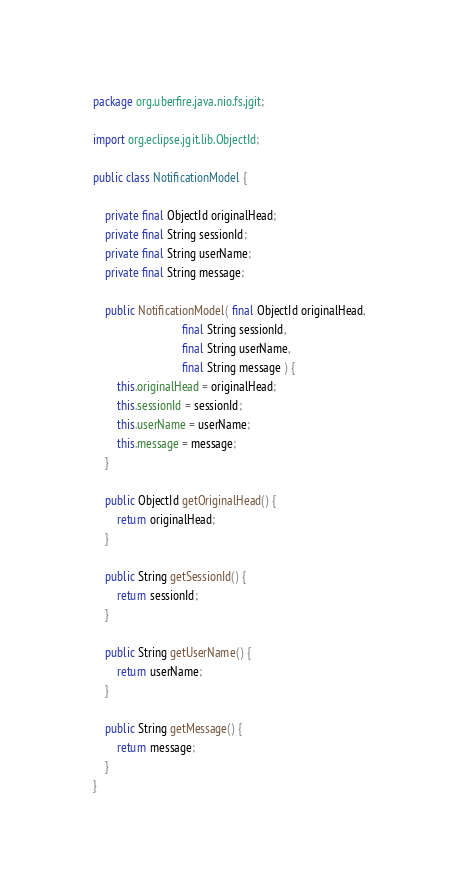<code> <loc_0><loc_0><loc_500><loc_500><_Java_>package org.uberfire.java.nio.fs.jgit;

import org.eclipse.jgit.lib.ObjectId;

public class NotificationModel {

    private final ObjectId originalHead;
    private final String sessionId;
    private final String userName;
    private final String message;

    public NotificationModel( final ObjectId originalHead,
                              final String sessionId,
                              final String userName,
                              final String message ) {
        this.originalHead = originalHead;
        this.sessionId = sessionId;
        this.userName = userName;
        this.message = message;
    }

    public ObjectId getOriginalHead() {
        return originalHead;
    }

    public String getSessionId() {
        return sessionId;
    }

    public String getUserName() {
        return userName;
    }

    public String getMessage() {
        return message;
    }
}
</code> 